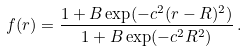<formula> <loc_0><loc_0><loc_500><loc_500>f ( r ) = \frac { 1 + B \exp ( - c ^ { 2 } ( r - R ) ^ { 2 } ) } { 1 + B \exp ( - c ^ { 2 } R ^ { 2 } ) } \, .</formula> 